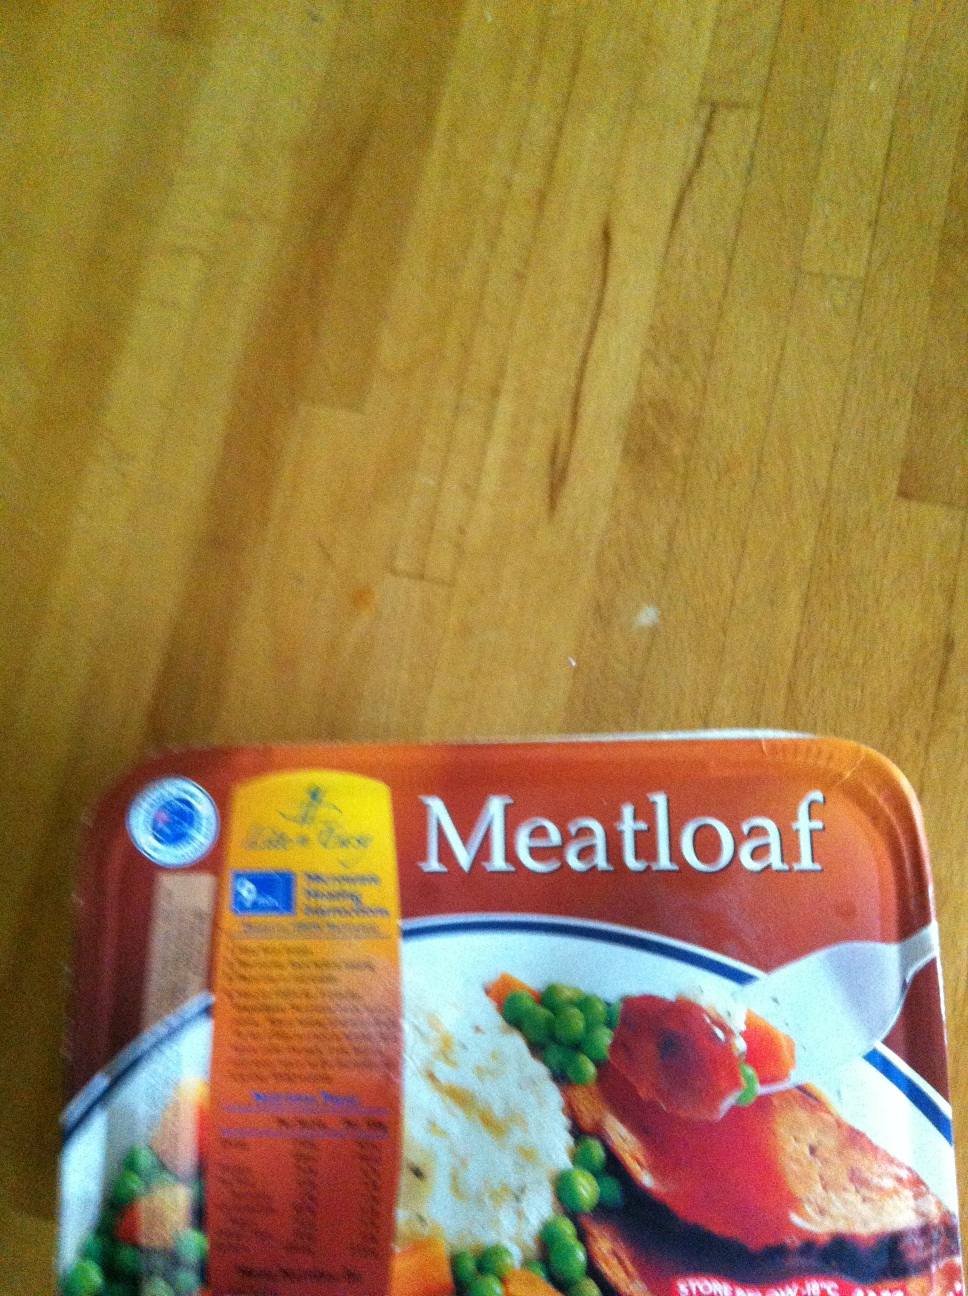Can you describe the packaging design and any notable details about it? The packaging design is quite eye-catching with a warm color scheme dominated by orange and white. The word 'Meatloaf' is prominently displayed in bold white letters, making it easy to identify the meal at a glance. A section of the packaging provides nutritional information along with a brand logo that signifies quality. The image also features a serving suggestion with meatloaf, mashed potatoes, and vegetables arranged neatly on a plate, giving potential buyers a visual idea of what to expect inside. 